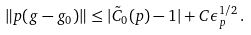Convert formula to latex. <formula><loc_0><loc_0><loc_500><loc_500>\| p ( g - g _ { 0 } ) \| \leq | \tilde { C } _ { 0 } ( p ) - 1 | + C \epsilon _ { p } ^ { 1 / 2 } \, .</formula> 